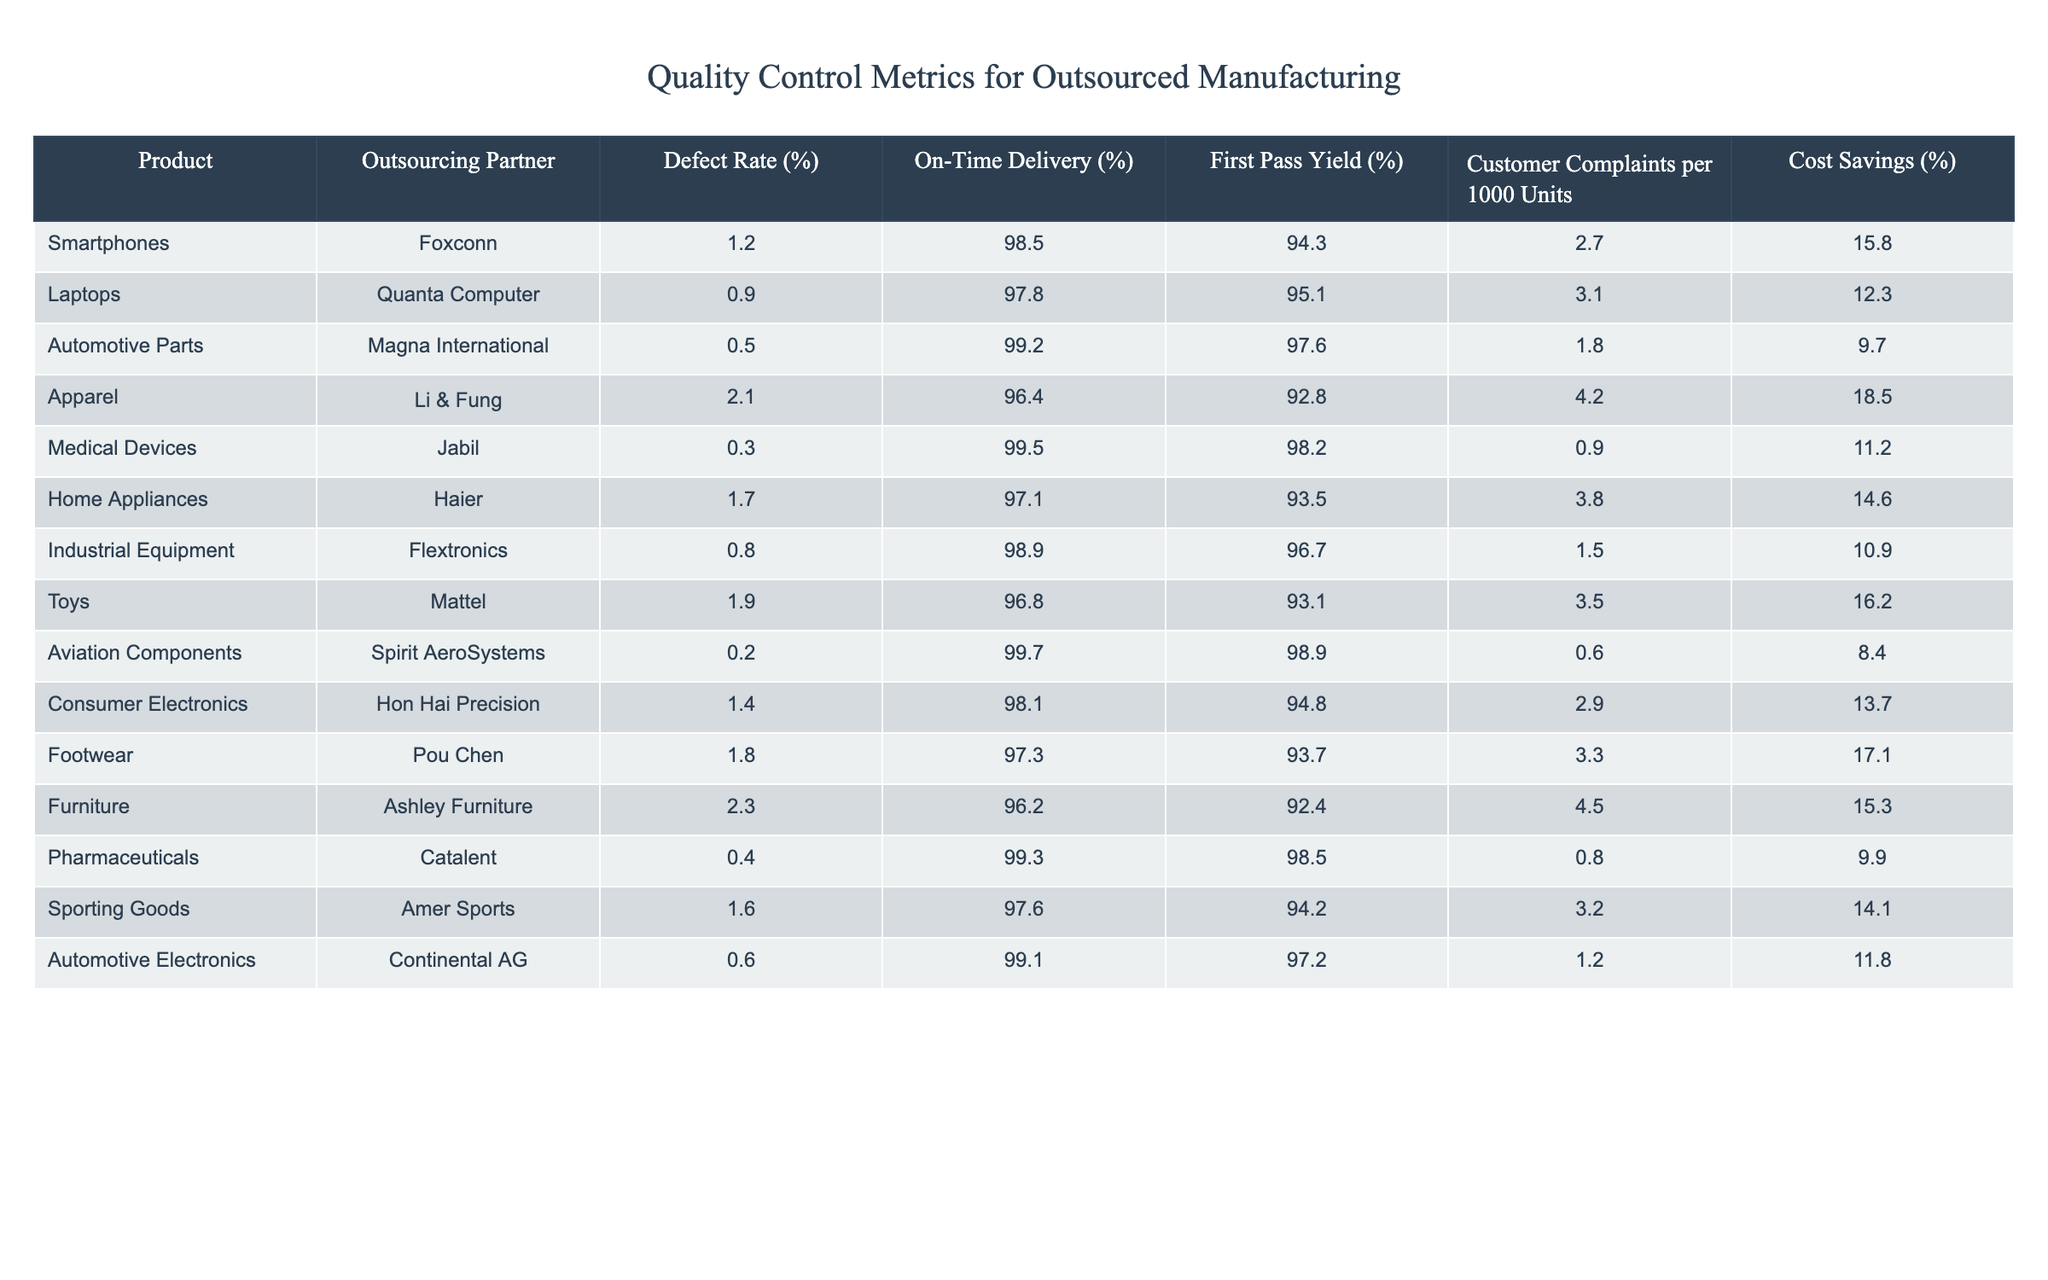What is the defect rate of medical devices produced by Jabil? The defect rate for medical devices, which are produced by Jabil, is listed in the table as 0.3%.
Answer: 0.3% Which outsourcing partner has the highest customer complaints per 1,000 units? By reviewing the customer complaints column, the highest value is 4.5 complaints per 1,000 units, which corresponds to Ashley Furniture.
Answer: Ashley Furniture What is the average defect rate across all products in the table? To find the average defect rate, sum the defect rates for all products (1.2 + 0.9 + 0.5 + 2.1 + 0.3 + 1.7 + 0.8 + 1.9 + 0.2 + 1.4 + 1.8 + 2.3 + 0.4 + 1.6 + 0.6) = 16.3%, and then divide by the number of products (15), resulting in an average defect rate of 16.3 / 15 = 1.09%.
Answer: 1.09% Is it true that all products manufactured by Foxconn have a defect rate below 2%? Reviewing the table, Foxconn manufactures smartphones with a defect rate of 1.2%, which is below 2%, hence it confirms that their only product listed does meet this criterion.
Answer: Yes Which outsourcing partner has the lowest on-time delivery percentage, and what is that percentage? Looking at the on-time delivery percentages, the lowest value is 96.2%, attributed to Ashley Furniture, which shows it has the lowest on-time delivery percentage among the listed partners.
Answer: Ashley Furniture, 96.2% If we combine the cost savings from laptops (12.3%) and medical devices (11.2%), what total percentage do we obtain? Adding the cost savings percentages from laptops and medical devices (12.3 + 11.2) results in 23.5%.
Answer: 23.5% What outsourcing partner achieved the highest first pass yield percentage? After examining the first pass yield percentages, Aviation Components from Spirit AeroSystems stands out with the highest yield at 98.9%.
Answer: Spirit AeroSystems Does the data indicate that automotive parts have the best overall performance regarding defect rate, first pass yield, and on-time delivery? To verify this, we look at Magna International for automotive parts, where the defect rate is 0.5%, first pass yield is 97.6%, and on-time delivery is 99.2%. Comparing these values with others in the table confirms automotive parts have very strong metrics.
Answer: Yes 